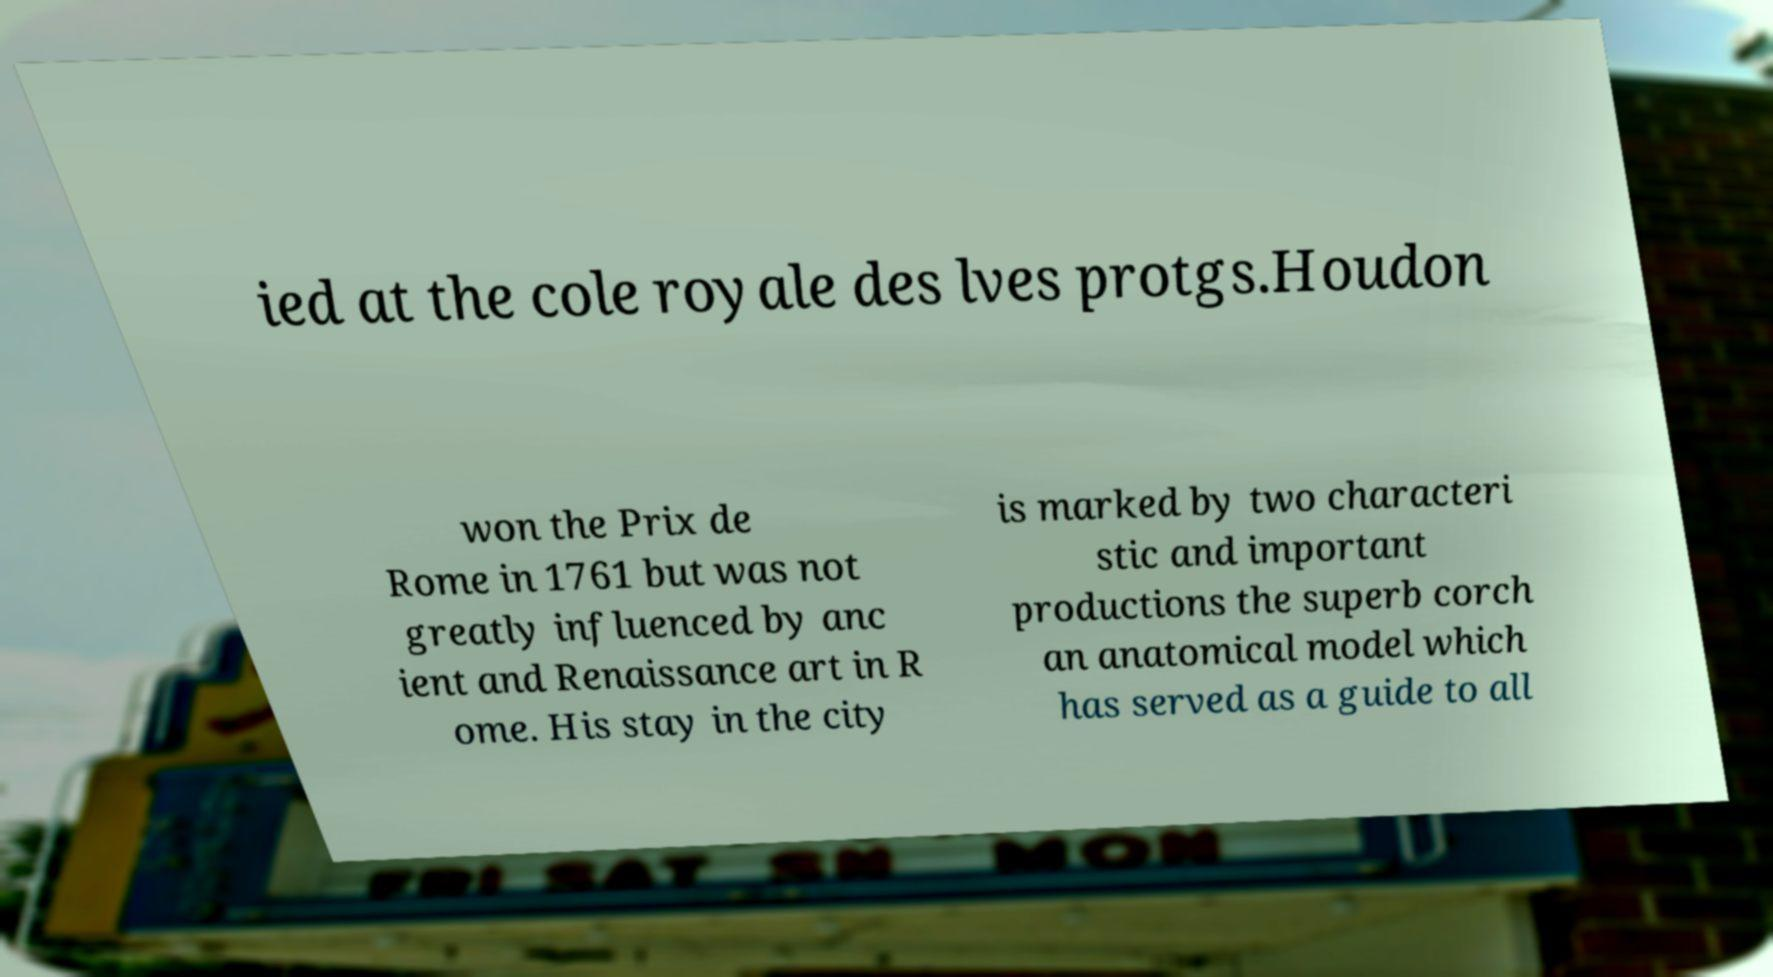There's text embedded in this image that I need extracted. Can you transcribe it verbatim? ied at the cole royale des lves protgs.Houdon won the Prix de Rome in 1761 but was not greatly influenced by anc ient and Renaissance art in R ome. His stay in the city is marked by two characteri stic and important productions the superb corch an anatomical model which has served as a guide to all 